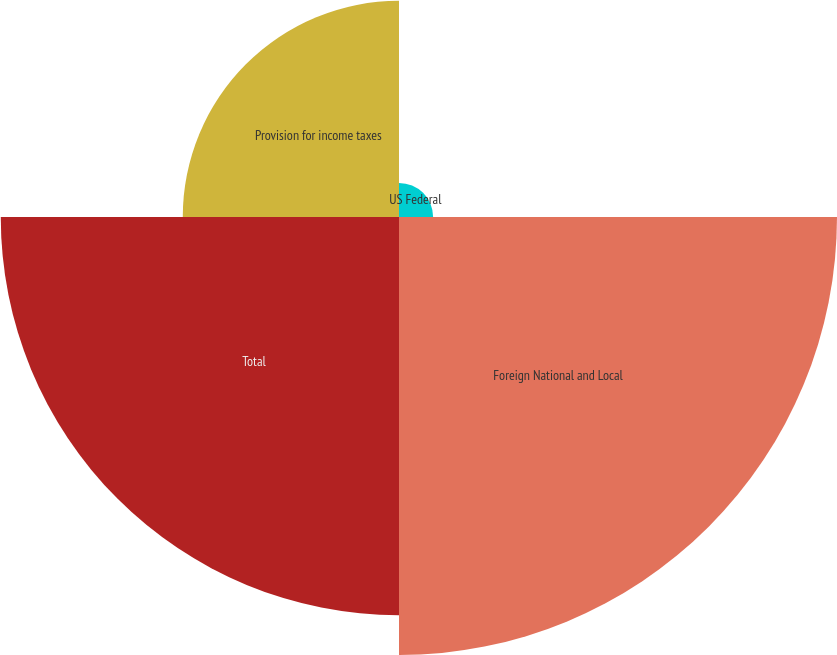Convert chart. <chart><loc_0><loc_0><loc_500><loc_500><pie_chart><fcel>US Federal<fcel>Foreign National and Local<fcel>Total<fcel>Provision for income taxes<nl><fcel>3.14%<fcel>40.31%<fcel>36.65%<fcel>19.9%<nl></chart> 